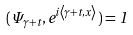<formula> <loc_0><loc_0><loc_500><loc_500>( \Psi _ { \gamma + t } , e ^ { i \left \langle \gamma + t , x \right \rangle } ) = 1</formula> 